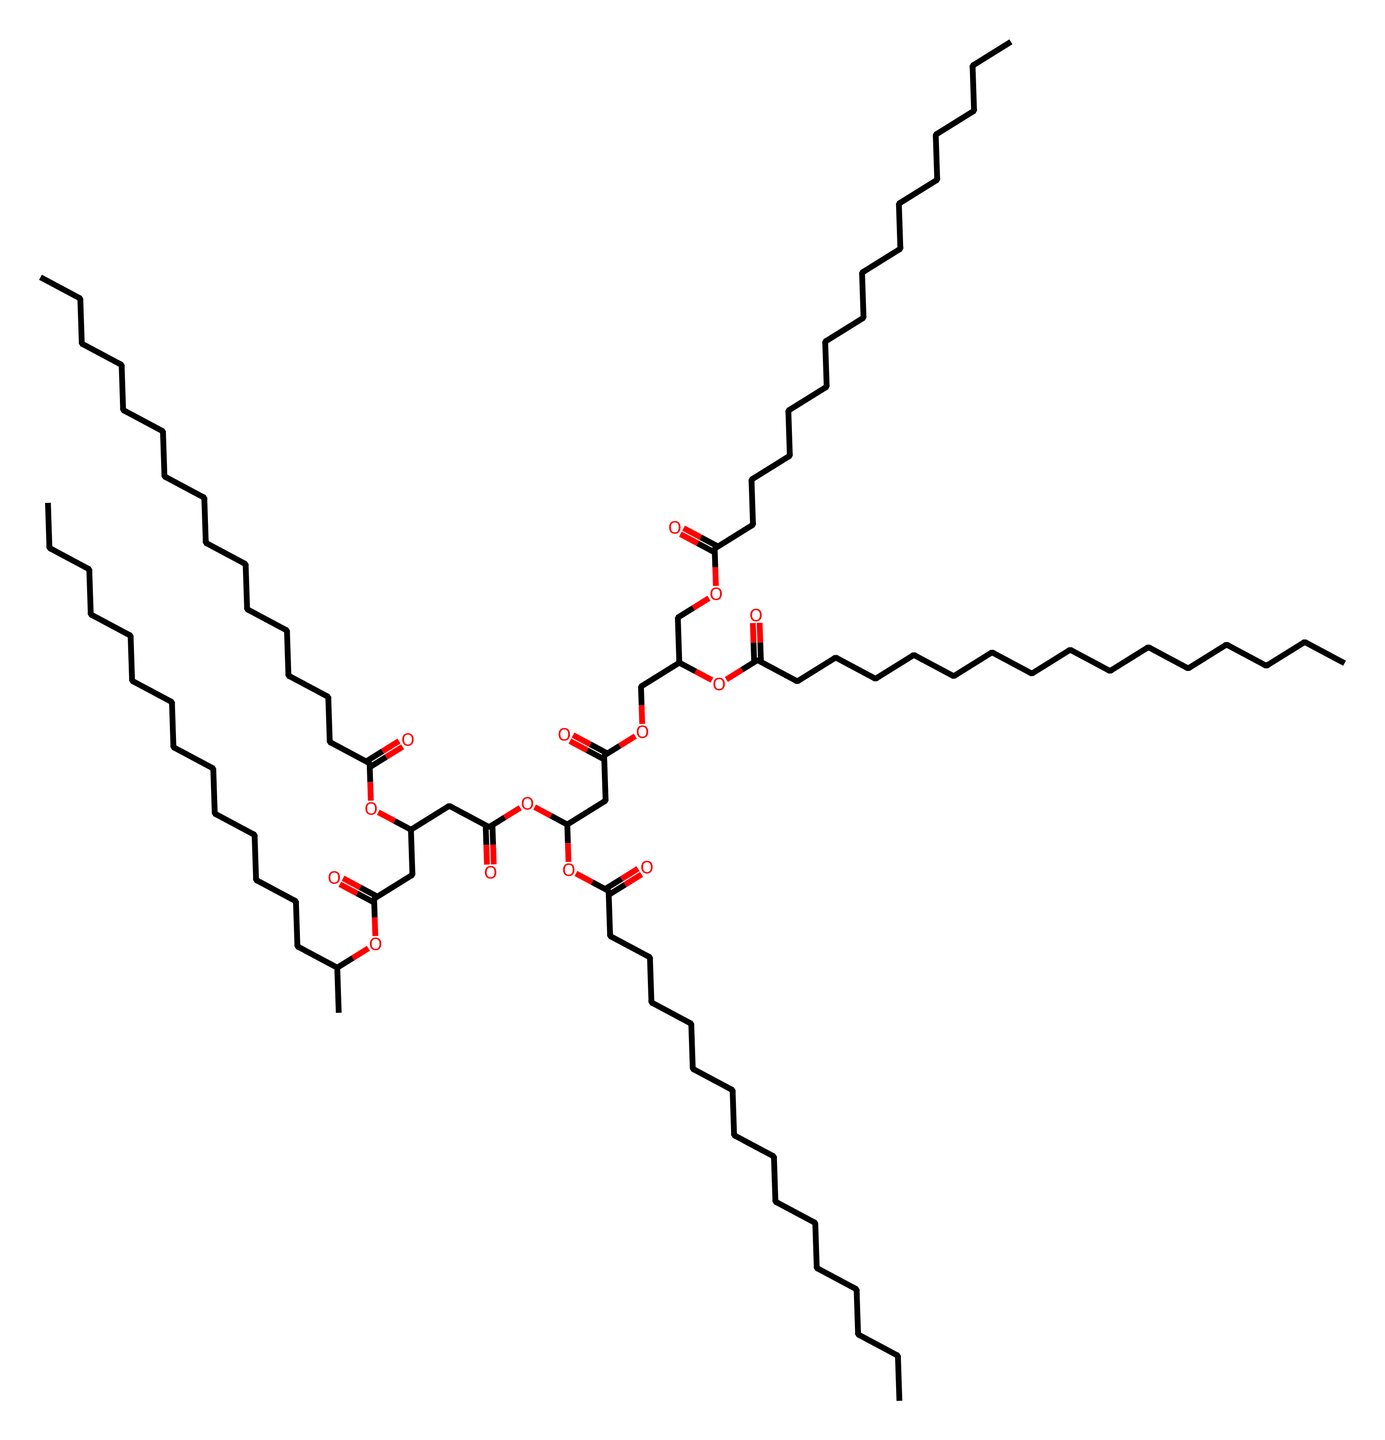How many carbon atoms are present in this molecule? By analyzing the SMILES representation, we count the number of "C" characters to identify the total number of carbon atoms. In this case, there are 28 carbon atoms.
Answer: 28 What type of functional groups can be identified from the structure? The presence of "O" suggests the presence of ether and ester groups due to the appearance of "C(=O)" indicating carbonyls. Additionally, "OC" depicts ether-like connections.
Answer: ether and ester Is the structure likely to be a solid, liquid, or gas at room temperature? The long carbon chains and presence of functional groups indicate that this molecule is a liquid under standard conditions, as most hydrocarbons of similar structures are liquids.
Answer: liquid What is the molecular formula of lamp oil represented by this SMILES? To determine the molecular formula, we count the atoms for each element based on the SMILES. This molecule contains 28 carbons, 54 hydrogens, and 6 oxygens leading to a molecular formula of C28H54O6.
Answer: C28H54O6 How many functional groups does this molecule contain? By examining the different occurrences of ester and ether groups in the SMILES, we identify a total of 5 functional groups. Each "OC(=O)" or "C(=O)O" denotes these functionalities.
Answer: 5 What properties would suggest that this molecule is flammable? The presence of multiple carbon and hydrogen atoms means it is likely to combust easily in the presence of oxygen, indicating it has characteristics of flammability.
Answer: flammable 